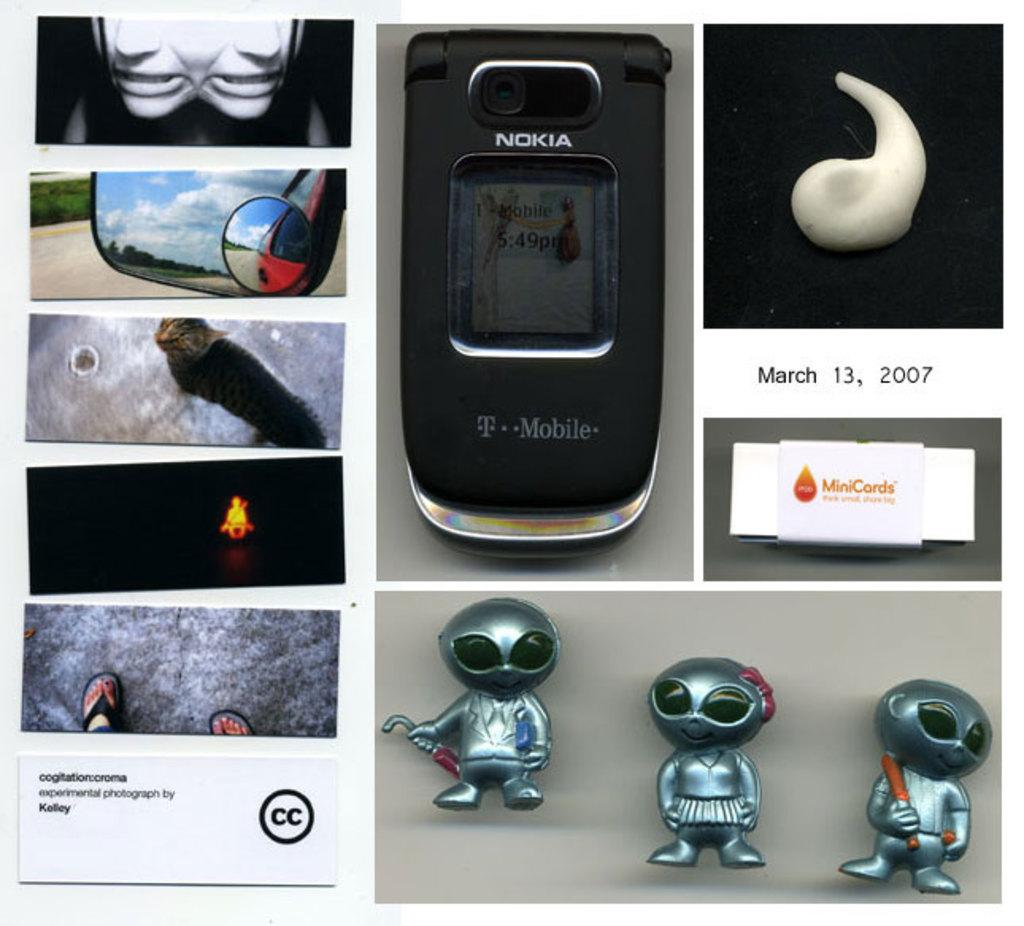<image>
Share a concise interpretation of the image provided. Various images, including a Nokia cellphone, little alien figurines and photos of cropped objects. 